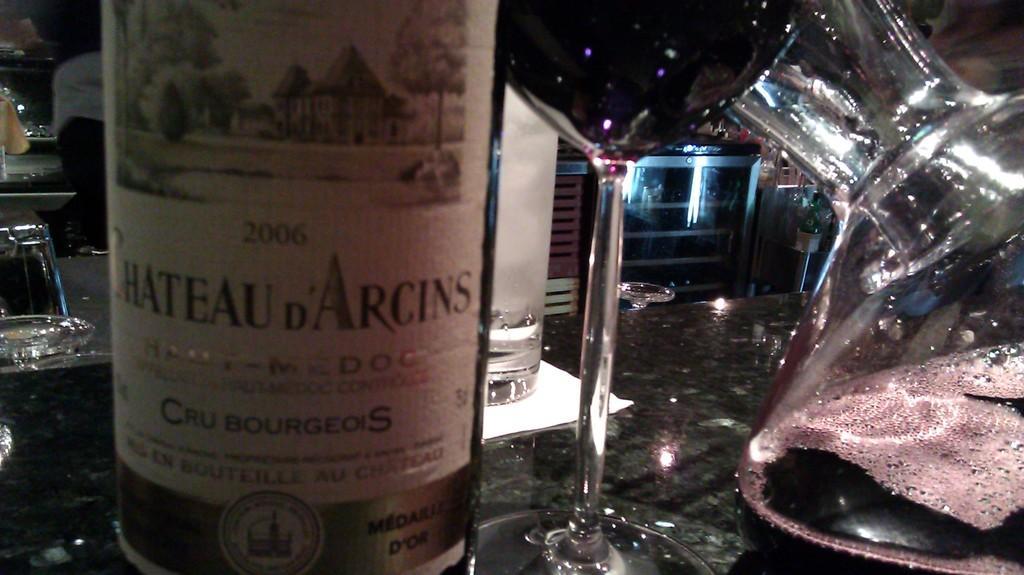In one or two sentences, can you explain what this image depicts? This might be a picture taken in a bar. In the foreground of the picture there is a table, on the table there is a jar there is a bottle and glasses. In the background there is a desk. On the left there are classes any person seated. 